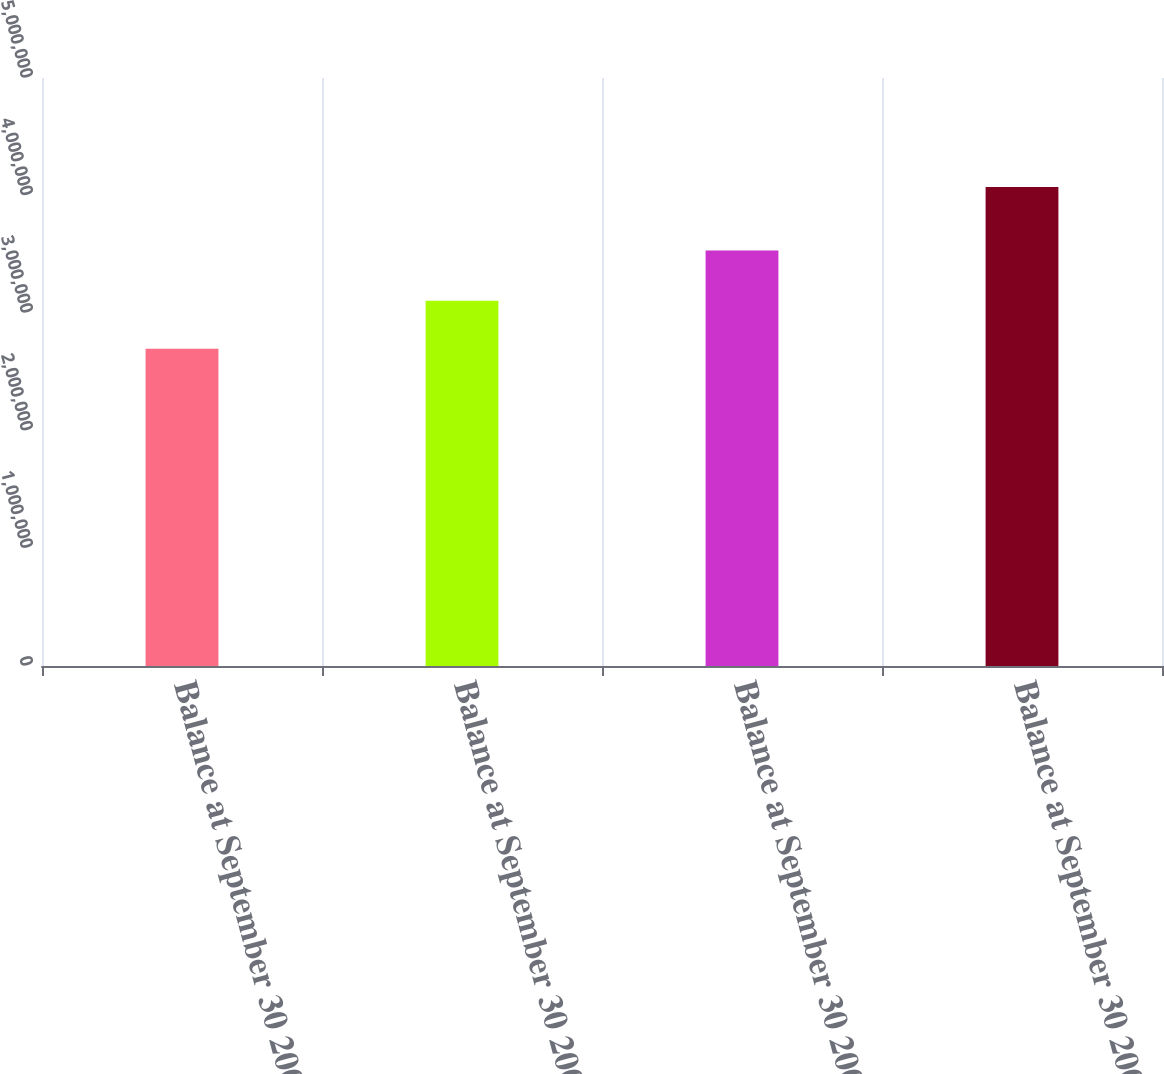Convert chart. <chart><loc_0><loc_0><loc_500><loc_500><bar_chart><fcel>Balance at September 30 2006<fcel>Balance at September 30 2007<fcel>Balance at September 30 2008<fcel>Balance at September 30 2009<nl><fcel>2.69802e+06<fcel>3.10589e+06<fcel>3.5324e+06<fcel>4.0737e+06<nl></chart> 